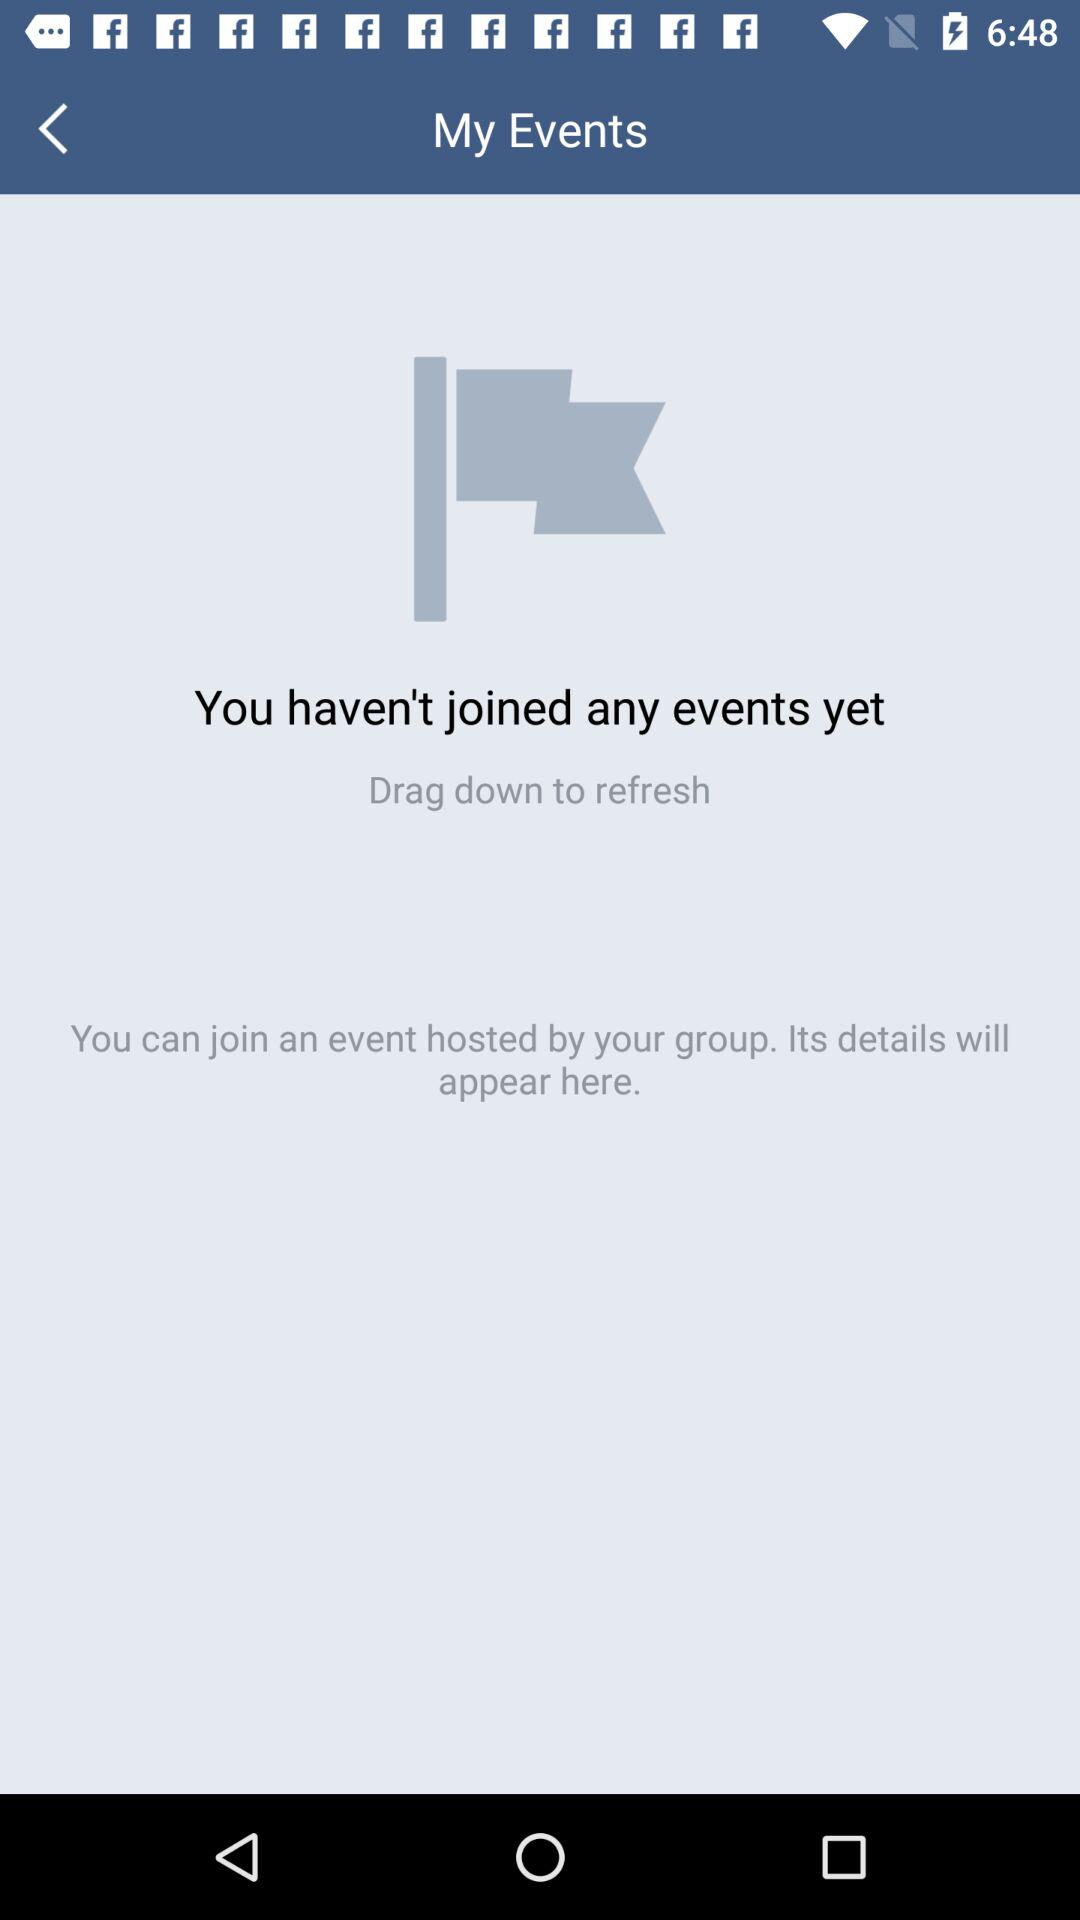How many events have I joined?
Answer the question using a single word or phrase. 0 